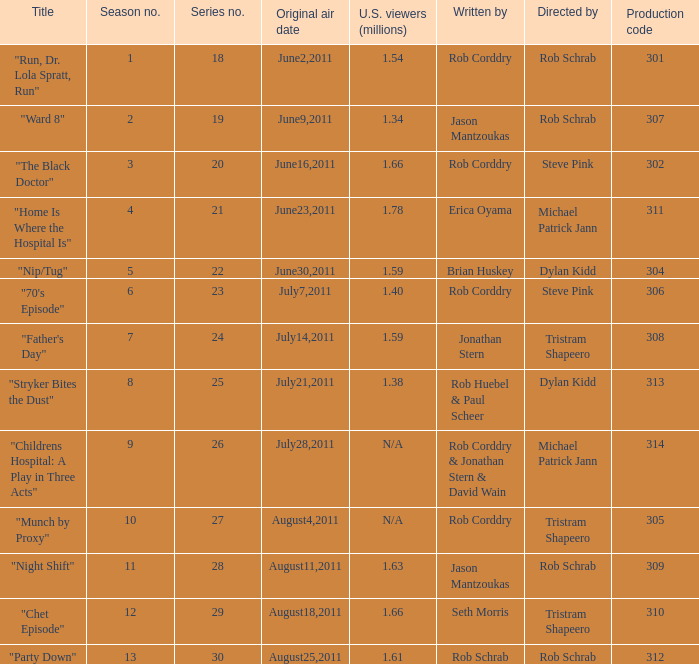At most what number in the series was the episode "chet episode"? 29.0. 